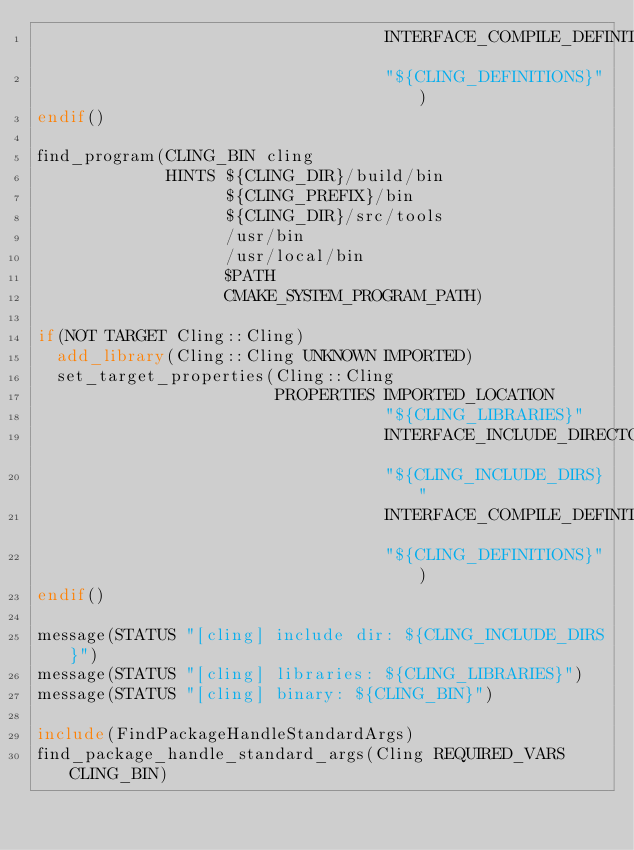Convert code to text. <code><loc_0><loc_0><loc_500><loc_500><_CMake_>                                   INTERFACE_COMPILE_DEFINITIONS
                                   "${CLING_DEFINITIONS}")
endif()

find_program(CLING_BIN cling
             HINTS ${CLING_DIR}/build/bin
                   ${CLING_PREFIX}/bin
                   ${CLING_DIR}/src/tools
                   /usr/bin
                   /usr/local/bin
                   $PATH
                   CMAKE_SYSTEM_PROGRAM_PATH)

if(NOT TARGET Cling::Cling)
  add_library(Cling::Cling UNKNOWN IMPORTED)
  set_target_properties(Cling::Cling
                        PROPERTIES IMPORTED_LOCATION
                                   "${CLING_LIBRARIES}"
                                   INTERFACE_INCLUDE_DIRECTORIES
                                   "${CLING_INCLUDE_DIRS}"
                                   INTERFACE_COMPILE_DEFINITIONS
                                   "${CLING_DEFINITIONS}")
endif()

message(STATUS "[cling] include dir: ${CLING_INCLUDE_DIRS}")
message(STATUS "[cling] libraries: ${CLING_LIBRARIES}")
message(STATUS "[cling] binary: ${CLING_BIN}")

include(FindPackageHandleStandardArgs)
find_package_handle_standard_args(Cling REQUIRED_VARS CLING_BIN)
</code> 